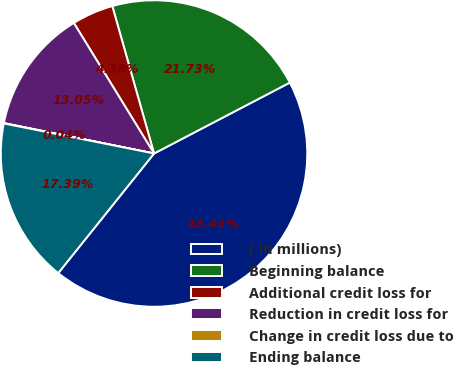Convert chart to OTSL. <chart><loc_0><loc_0><loc_500><loc_500><pie_chart><fcel>( in millions)<fcel>Beginning balance<fcel>Additional credit loss for<fcel>Reduction in credit loss for<fcel>Change in credit loss due to<fcel>Ending balance<nl><fcel>43.41%<fcel>21.73%<fcel>4.38%<fcel>13.05%<fcel>0.04%<fcel>17.39%<nl></chart> 